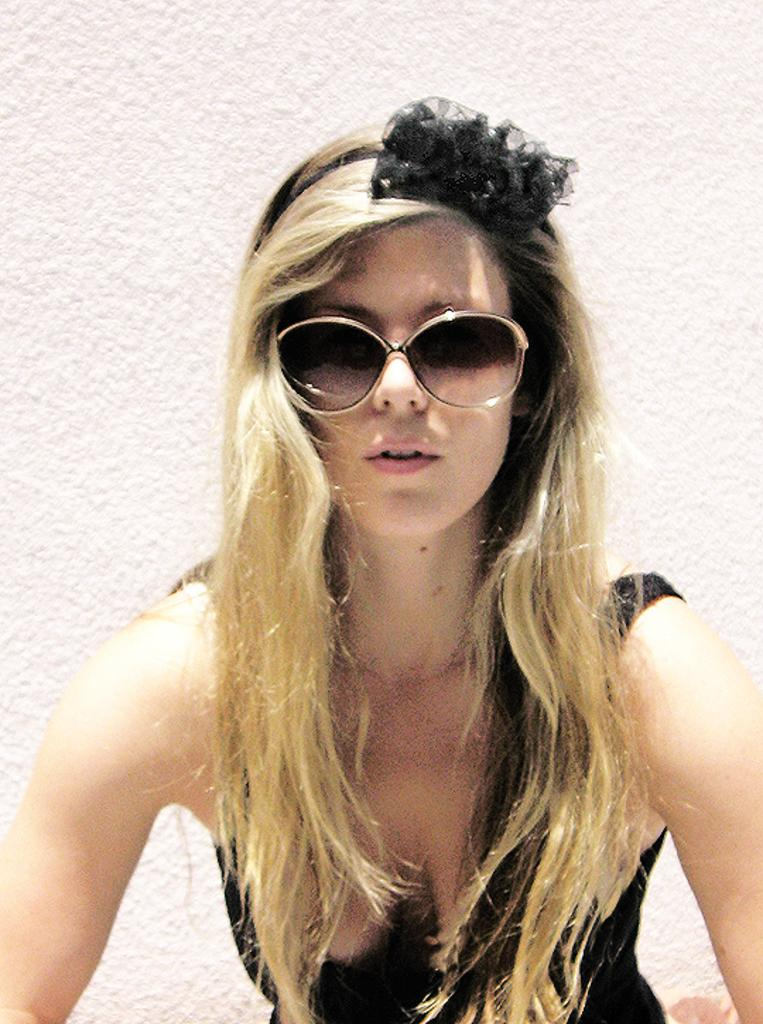Who is the main subject in the image? There is a woman in the image. What is a notable feature of the woman's appearance? The woman has blond hair. What is the woman wearing in the image? The woman is wearing a black top. Where is the woman standing in the image? The woman is standing in front of a wall. What accessory is the woman wearing in the image? The woman is wearing glasses. What type of agreement is being signed by the woman in the image? There is no indication in the image that the woman is signing any agreement. How many rays of light can be seen coming from the woman's hands in the image? There are no rays of light visible in the image, and the woman's hands are not shown. 